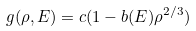<formula> <loc_0><loc_0><loc_500><loc_500>g ( \rho , E ) = c ( 1 - b ( E ) \rho ^ { 2 / 3 } )</formula> 